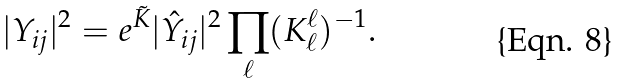<formula> <loc_0><loc_0><loc_500><loc_500>| Y _ { i j } | ^ { 2 } = e ^ { \tilde { K } } | \hat { Y } _ { i j } | ^ { 2 } \prod _ { \ell } ( K ^ { \ell } _ { \ell } ) ^ { - 1 } .</formula> 